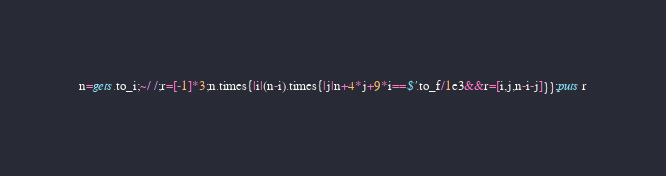<code> <loc_0><loc_0><loc_500><loc_500><_Ruby_>n=gets.to_i;~/ /;r=[-1]*3;n.times{|i|(n-i).times{|j|n+4*j+9*i==$'.to_f/1e3&&r=[i,j,n-i-j]}};puts r</code> 